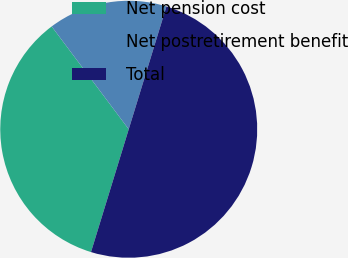<chart> <loc_0><loc_0><loc_500><loc_500><pie_chart><fcel>Net pension cost<fcel>Net postretirement benefit<fcel>Total<nl><fcel>35.02%<fcel>14.98%<fcel>50.0%<nl></chart> 